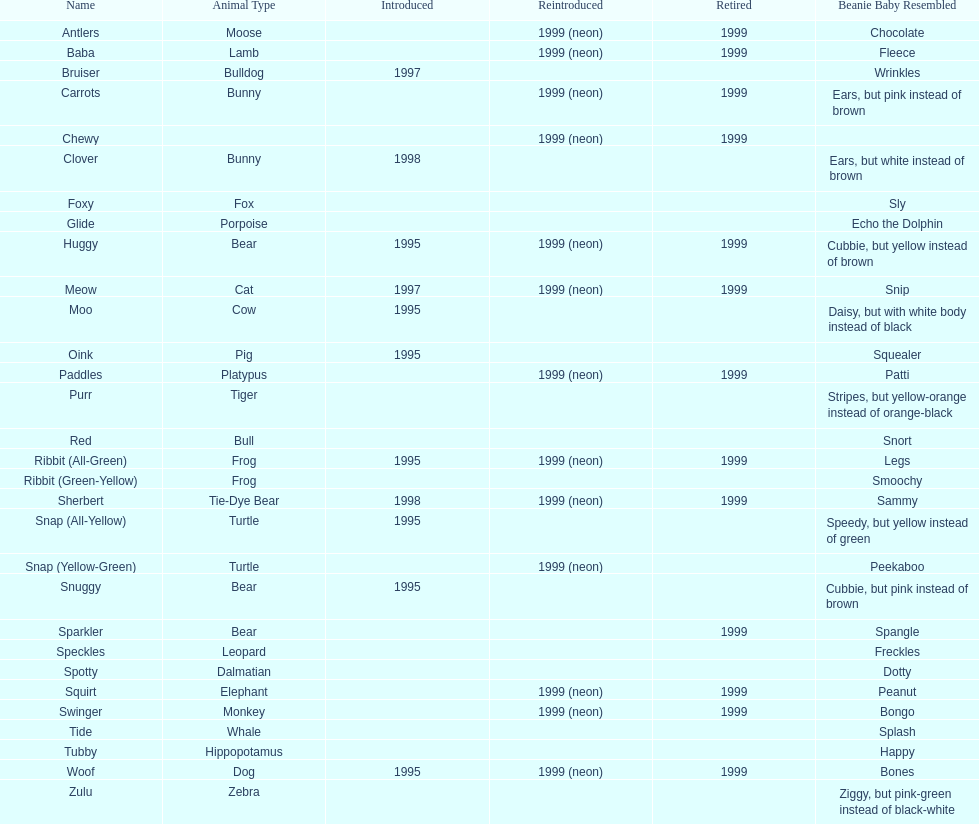What creatures are pillow pals? Moose, Lamb, Bulldog, Bunny, Bunny, Fox, Porpoise, Bear, Cat, Cow, Pig, Platypus, Tiger, Bull, Frog, Frog, Tie-Dye Bear, Turtle, Turtle, Bear, Bear, Leopard, Dalmatian, Elephant, Monkey, Whale, Hippopotamus, Dog, Zebra. What is the name of the dalmatian? Spotty. 